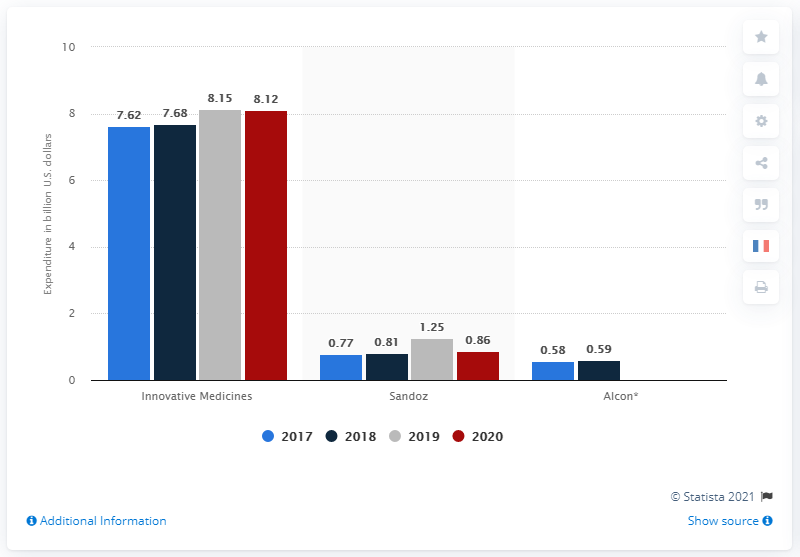Mention a couple of crucial points in this snapshot. Novartis spent billions of dollars in both 2019 and 2020 on their Innovative Medicines division, which focuses on the research and development of new and innovative drugs and treatments. 